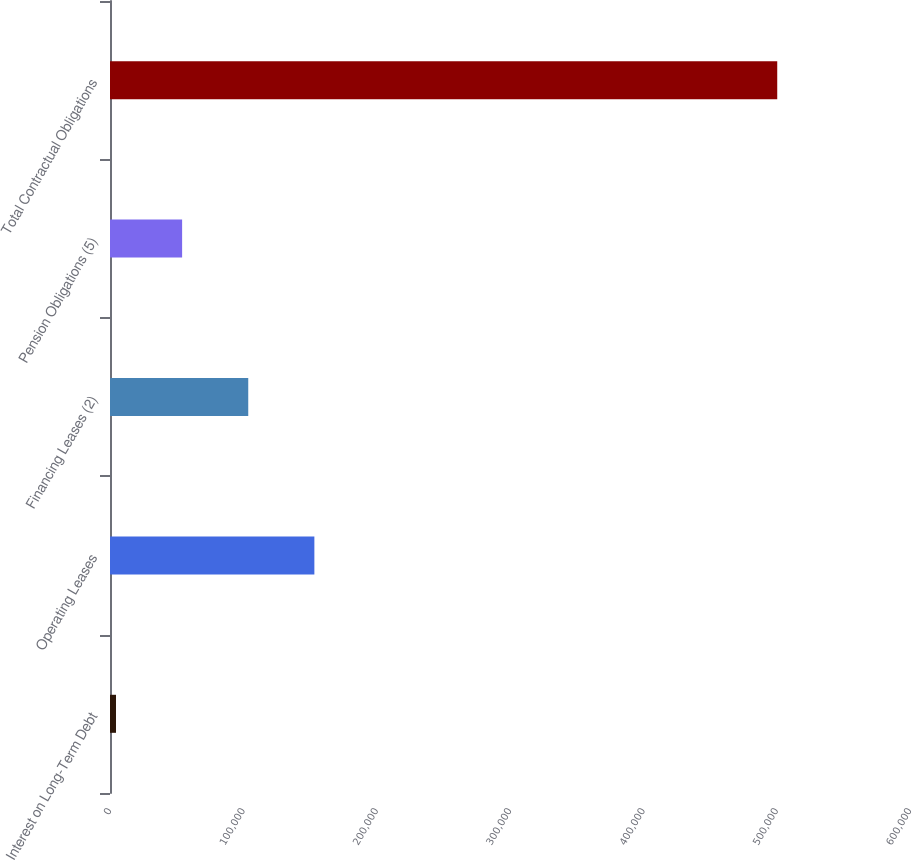<chart> <loc_0><loc_0><loc_500><loc_500><bar_chart><fcel>Interest on Long-Term Debt<fcel>Operating Leases<fcel>Financing Leases (2)<fcel>Pension Obligations (5)<fcel>Total Contractual Obligations<nl><fcel>4500<fcel>153278<fcel>103685<fcel>54092.7<fcel>500427<nl></chart> 